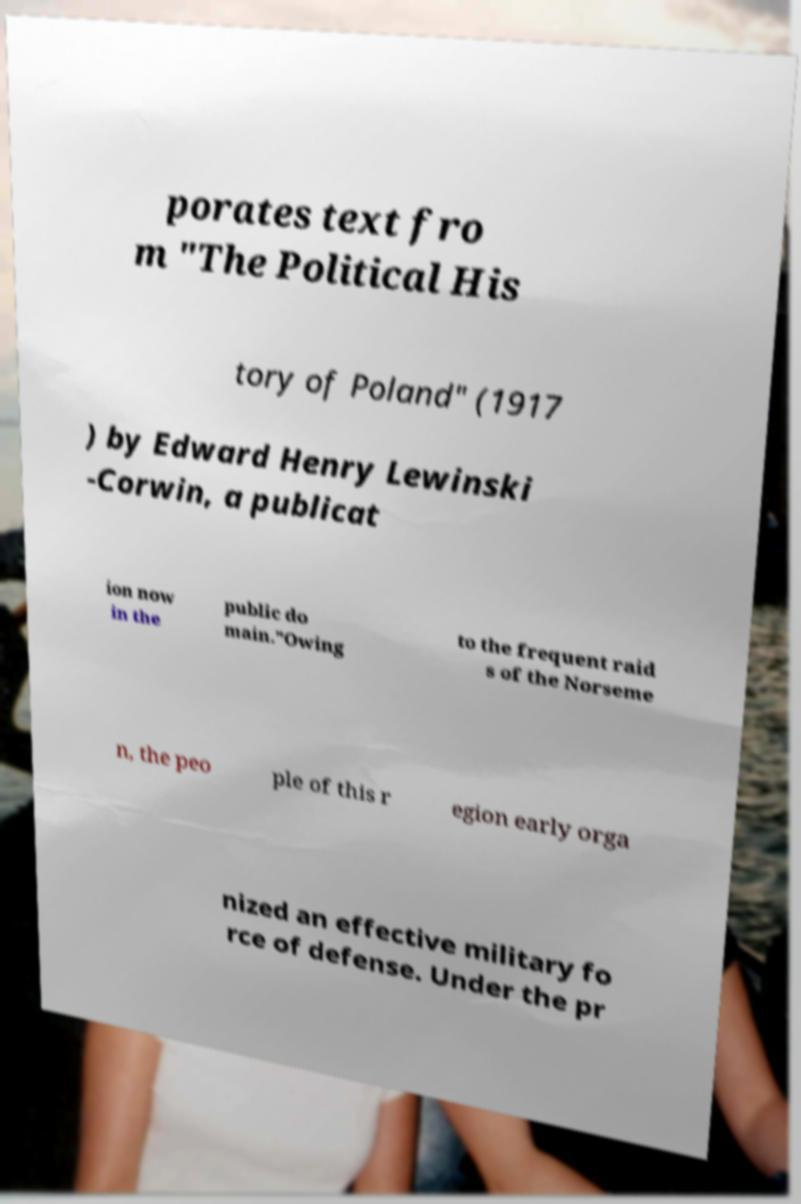Could you assist in decoding the text presented in this image and type it out clearly? porates text fro m "The Political His tory of Poland" (1917 ) by Edward Henry Lewinski -Corwin, a publicat ion now in the public do main."Owing to the frequent raid s of the Norseme n, the peo ple of this r egion early orga nized an effective military fo rce of defense. Under the pr 